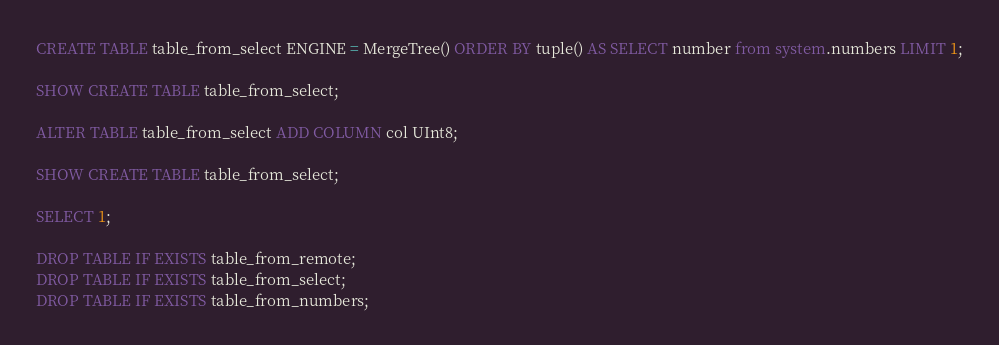Convert code to text. <code><loc_0><loc_0><loc_500><loc_500><_SQL_>CREATE TABLE table_from_select ENGINE = MergeTree() ORDER BY tuple() AS SELECT number from system.numbers LIMIT 1;

SHOW CREATE TABLE table_from_select;

ALTER TABLE table_from_select ADD COLUMN col UInt8;

SHOW CREATE TABLE table_from_select;

SELECT 1;

DROP TABLE IF EXISTS table_from_remote;
DROP TABLE IF EXISTS table_from_select;
DROP TABLE IF EXISTS table_from_numbers;
</code> 